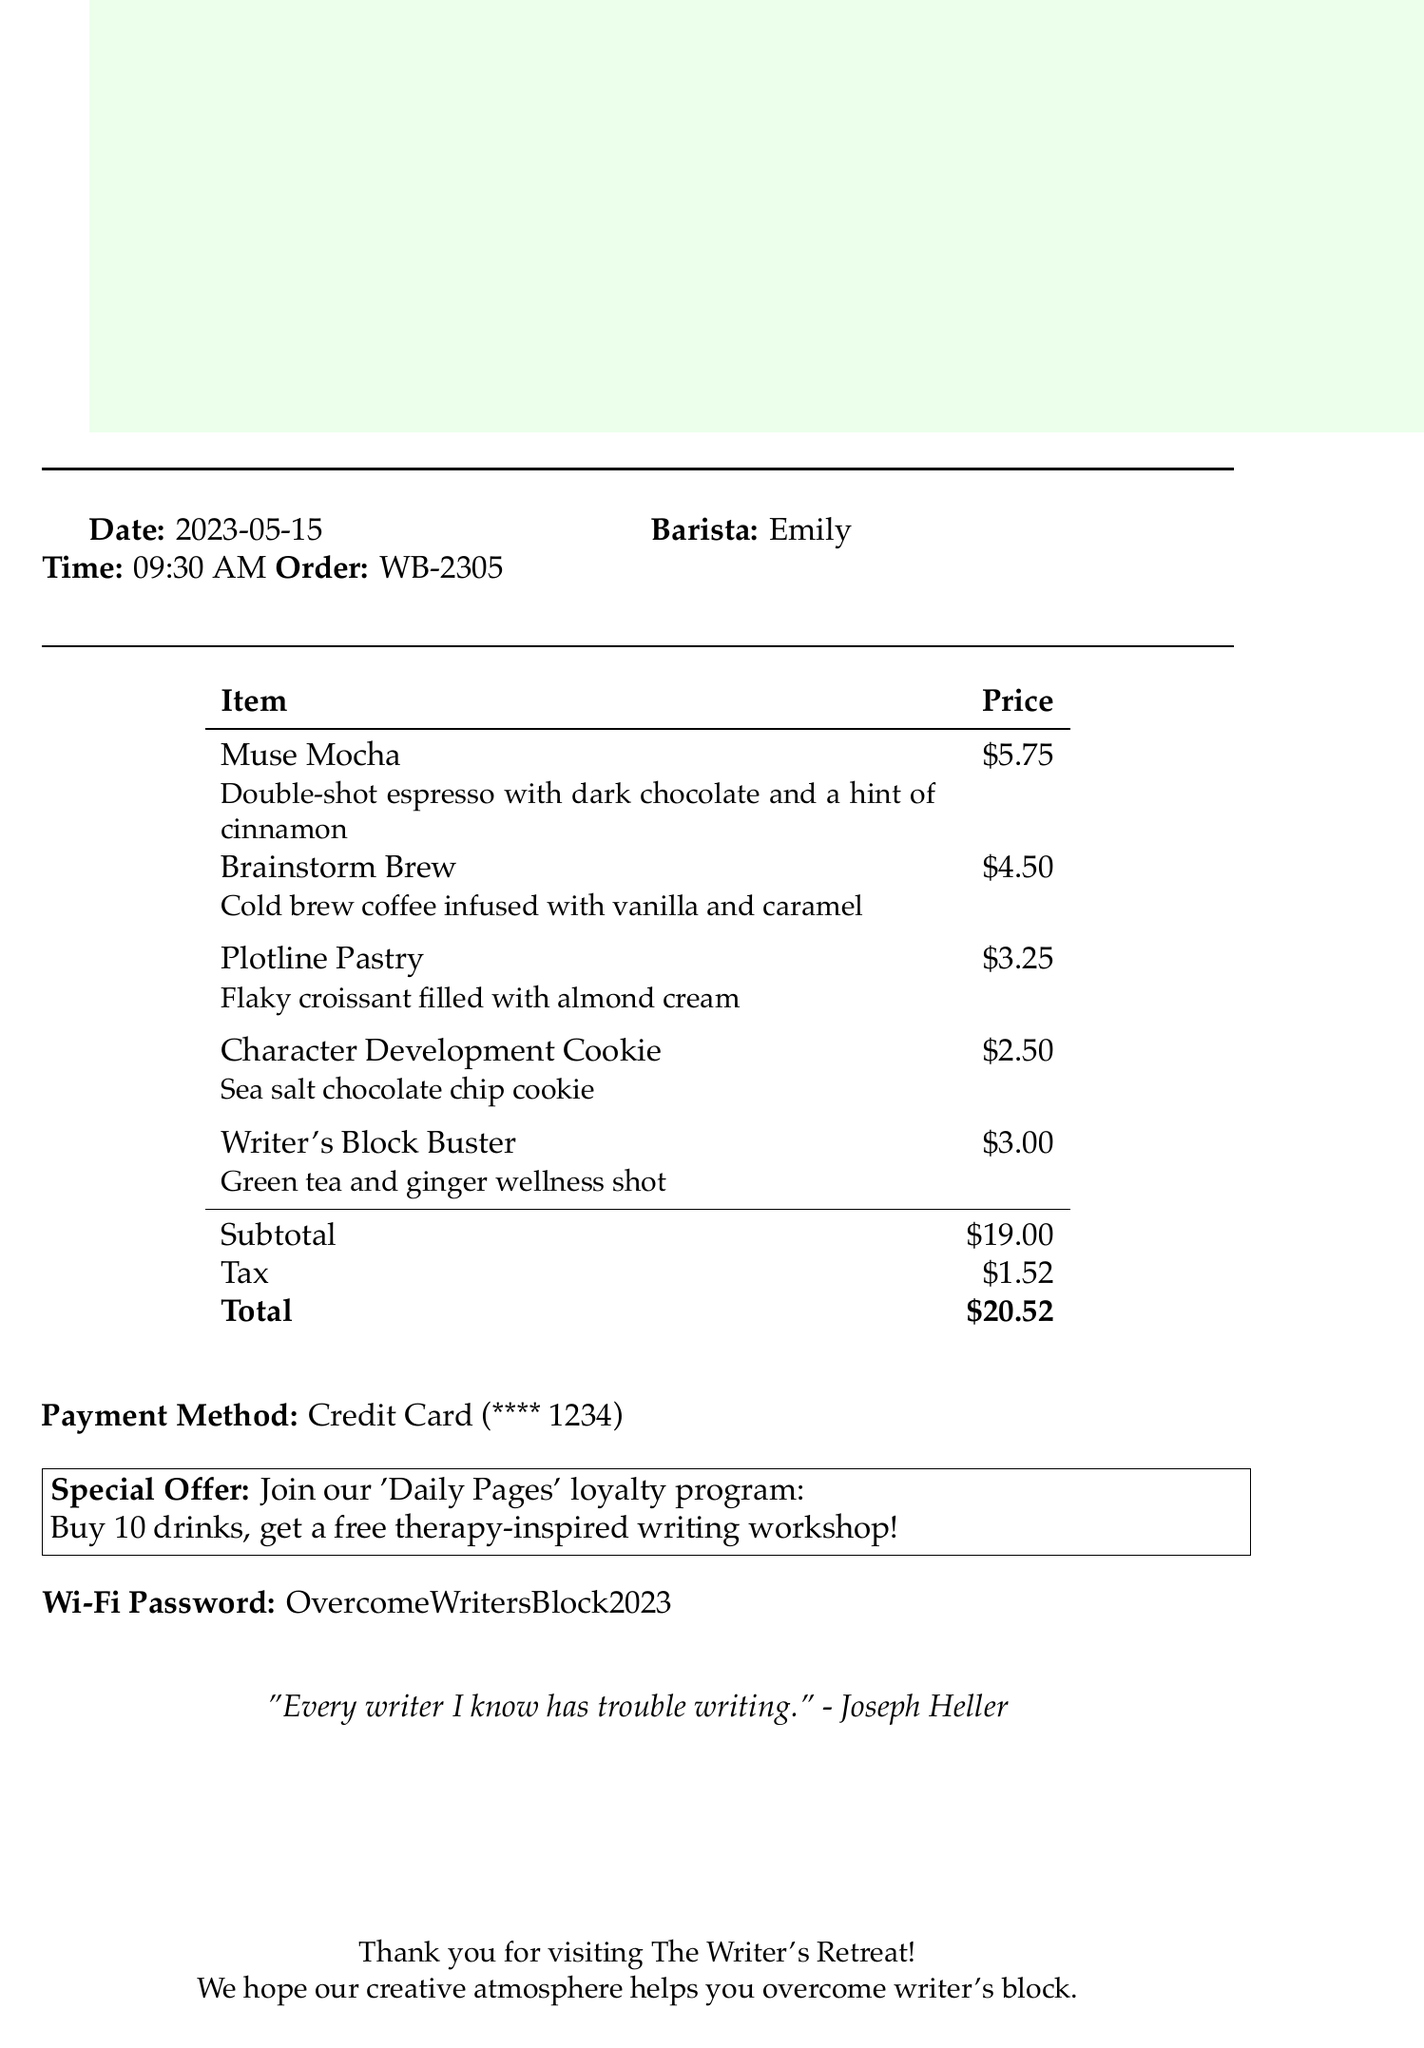What is the name of the cafe? The name of the cafe is prominently displayed at the top of the document.
Answer: The Writer's Retreat What is the address of the cafe? The address is provided below the cafe name in the document.
Answer: 123 Inspiration Lane, Creativity City What is the total amount of the order? The total amount appears in the totals section of the receipt.
Answer: $20.52 Who was the barista? The name of the barista is mentioned alongside the order details.
Answer: Emily What is one of the specialty drinks ordered? The receipt lists a number of drinks, one of which can be identified.
Answer: Muse Mocha How much does the "Brainstorm Brew" cost? The price of the "Brainstorm Brew" is listed in the order section of the document.
Answer: $4.50 What is the special offer at the cafe? The special offer is indicated in a boxed section within the receipt.
Answer: Buy 10 drinks, get a free therapy-inspired writing workshop! What is the Wi-Fi password? The Wi-Fi password is provided towards the end of the document.
Answer: OvercomeWritersBlock2023 What is the motivational quote included in the document? The motivational quote is presented in italics at the bottom of the document.
Answer: "Every writer I know has trouble writing." - Joseph Heller 